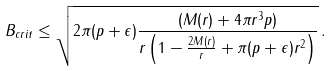<formula> <loc_0><loc_0><loc_500><loc_500>B _ { c r i t } \leq \sqrt { 2 \pi ( p + \epsilon ) \frac { ( M ( r ) + 4 \pi r ^ { 3 } p ) } { r \left ( 1 - \frac { 2 M ( r ) } { r } + \pi ( p + \epsilon ) r ^ { 2 } \right ) } } \, .</formula> 